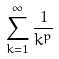<formula> <loc_0><loc_0><loc_500><loc_500>\sum _ { k = 1 } ^ { \infty } \frac { 1 } { k ^ { p } }</formula> 